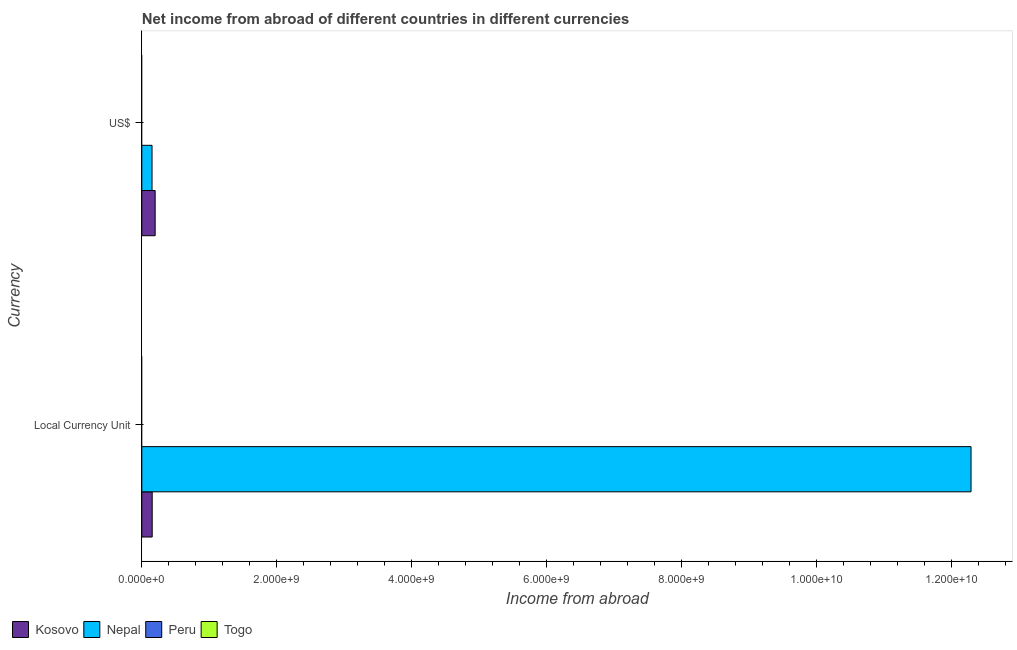How many bars are there on the 2nd tick from the top?
Provide a succinct answer. 2. What is the label of the 2nd group of bars from the top?
Your response must be concise. Local Currency Unit. Across all countries, what is the maximum income from abroad in constant 2005 us$?
Keep it short and to the point. 1.23e+1. In which country was the income from abroad in us$ maximum?
Your response must be concise. Kosovo. What is the total income from abroad in us$ in the graph?
Your answer should be very brief. 3.50e+08. What is the difference between the income from abroad in constant 2005 us$ in Nepal and that in Kosovo?
Your response must be concise. 1.21e+1. What is the average income from abroad in constant 2005 us$ per country?
Your answer should be very brief. 3.11e+09. What is the difference between the income from abroad in us$ and income from abroad in constant 2005 us$ in Nepal?
Make the answer very short. -1.21e+1. What is the ratio of the income from abroad in constant 2005 us$ in Nepal to that in Kosovo?
Your answer should be very brief. 79.75. Is the income from abroad in constant 2005 us$ in Kosovo less than that in Nepal?
Your answer should be compact. Yes. How many bars are there?
Your answer should be compact. 4. Are all the bars in the graph horizontal?
Your answer should be compact. Yes. What is the difference between two consecutive major ticks on the X-axis?
Give a very brief answer. 2.00e+09. How many legend labels are there?
Provide a succinct answer. 4. How are the legend labels stacked?
Your response must be concise. Horizontal. What is the title of the graph?
Ensure brevity in your answer.  Net income from abroad of different countries in different currencies. What is the label or title of the X-axis?
Give a very brief answer. Income from abroad. What is the label or title of the Y-axis?
Your response must be concise. Currency. What is the Income from abroad of Kosovo in Local Currency Unit?
Your response must be concise. 1.54e+08. What is the Income from abroad of Nepal in Local Currency Unit?
Offer a terse response. 1.23e+1. What is the Income from abroad of Peru in Local Currency Unit?
Provide a short and direct response. 0. What is the Income from abroad of Togo in Local Currency Unit?
Offer a very short reply. 0. What is the Income from abroad in Kosovo in US$?
Ensure brevity in your answer.  1.98e+08. What is the Income from abroad in Nepal in US$?
Provide a short and direct response. 1.52e+08. What is the Income from abroad in Peru in US$?
Provide a short and direct response. 0. What is the Income from abroad in Togo in US$?
Ensure brevity in your answer.  0. Across all Currency, what is the maximum Income from abroad of Kosovo?
Give a very brief answer. 1.98e+08. Across all Currency, what is the maximum Income from abroad of Nepal?
Offer a terse response. 1.23e+1. Across all Currency, what is the minimum Income from abroad of Kosovo?
Keep it short and to the point. 1.54e+08. Across all Currency, what is the minimum Income from abroad in Nepal?
Your answer should be compact. 1.52e+08. What is the total Income from abroad in Kosovo in the graph?
Provide a succinct answer. 3.52e+08. What is the total Income from abroad in Nepal in the graph?
Offer a terse response. 1.24e+1. What is the total Income from abroad of Peru in the graph?
Make the answer very short. 0. What is the total Income from abroad in Togo in the graph?
Your response must be concise. 0. What is the difference between the Income from abroad of Kosovo in Local Currency Unit and that in US$?
Keep it short and to the point. -4.39e+07. What is the difference between the Income from abroad of Nepal in Local Currency Unit and that in US$?
Offer a terse response. 1.21e+1. What is the difference between the Income from abroad in Kosovo in Local Currency Unit and the Income from abroad in Nepal in US$?
Your answer should be very brief. 2.42e+06. What is the average Income from abroad of Kosovo per Currency?
Ensure brevity in your answer.  1.76e+08. What is the average Income from abroad of Nepal per Currency?
Your response must be concise. 6.22e+09. What is the average Income from abroad of Peru per Currency?
Offer a very short reply. 0. What is the average Income from abroad in Togo per Currency?
Your answer should be very brief. 0. What is the difference between the Income from abroad of Kosovo and Income from abroad of Nepal in Local Currency Unit?
Your response must be concise. -1.21e+1. What is the difference between the Income from abroad of Kosovo and Income from abroad of Nepal in US$?
Your response must be concise. 4.63e+07. What is the ratio of the Income from abroad in Kosovo in Local Currency Unit to that in US$?
Offer a terse response. 0.78. What is the ratio of the Income from abroad of Nepal in Local Currency Unit to that in US$?
Give a very brief answer. 81.02. What is the difference between the highest and the second highest Income from abroad of Kosovo?
Your answer should be very brief. 4.39e+07. What is the difference between the highest and the second highest Income from abroad of Nepal?
Provide a succinct answer. 1.21e+1. What is the difference between the highest and the lowest Income from abroad in Kosovo?
Ensure brevity in your answer.  4.39e+07. What is the difference between the highest and the lowest Income from abroad of Nepal?
Keep it short and to the point. 1.21e+1. 